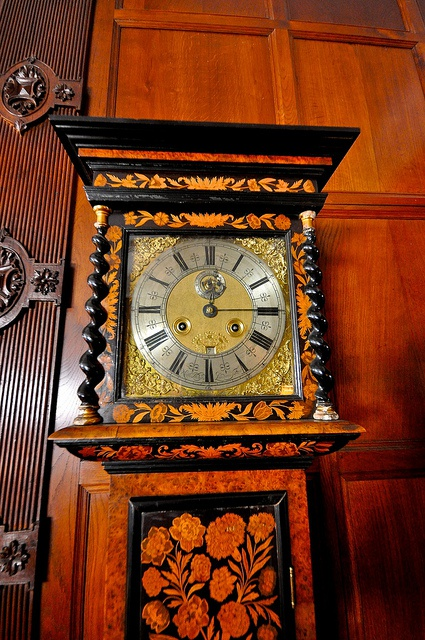Describe the objects in this image and their specific colors. I can see a clock in maroon, tan, darkgray, and gray tones in this image. 